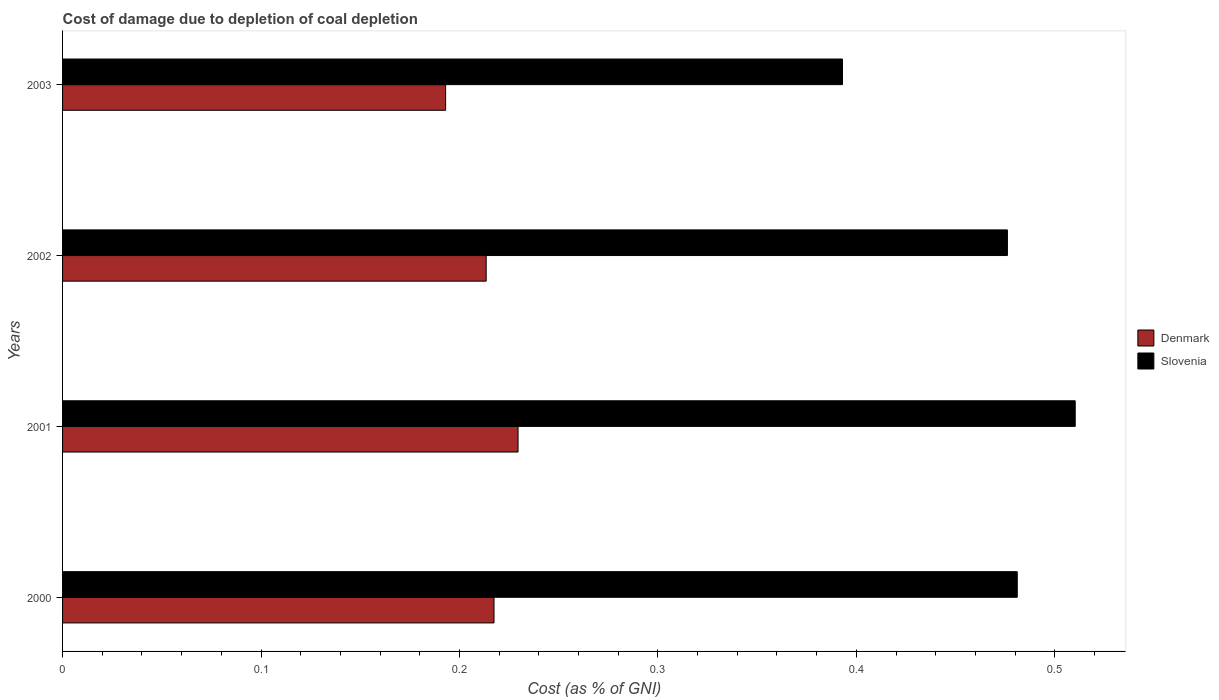Are the number of bars on each tick of the Y-axis equal?
Your answer should be compact. Yes. How many bars are there on the 4th tick from the top?
Your response must be concise. 2. How many bars are there on the 3rd tick from the bottom?
Offer a very short reply. 2. What is the label of the 1st group of bars from the top?
Provide a succinct answer. 2003. In how many cases, is the number of bars for a given year not equal to the number of legend labels?
Your response must be concise. 0. What is the cost of damage caused due to coal depletion in Slovenia in 2001?
Offer a terse response. 0.51. Across all years, what is the maximum cost of damage caused due to coal depletion in Slovenia?
Your answer should be compact. 0.51. Across all years, what is the minimum cost of damage caused due to coal depletion in Denmark?
Offer a terse response. 0.19. In which year was the cost of damage caused due to coal depletion in Slovenia maximum?
Give a very brief answer. 2001. What is the total cost of damage caused due to coal depletion in Slovenia in the graph?
Make the answer very short. 1.86. What is the difference between the cost of damage caused due to coal depletion in Denmark in 2002 and that in 2003?
Your answer should be compact. 0.02. What is the difference between the cost of damage caused due to coal depletion in Slovenia in 2003 and the cost of damage caused due to coal depletion in Denmark in 2002?
Make the answer very short. 0.18. What is the average cost of damage caused due to coal depletion in Slovenia per year?
Your answer should be very brief. 0.47. In the year 2000, what is the difference between the cost of damage caused due to coal depletion in Denmark and cost of damage caused due to coal depletion in Slovenia?
Your response must be concise. -0.26. What is the ratio of the cost of damage caused due to coal depletion in Slovenia in 2002 to that in 2003?
Offer a very short reply. 1.21. Is the cost of damage caused due to coal depletion in Denmark in 2001 less than that in 2003?
Provide a short and direct response. No. What is the difference between the highest and the second highest cost of damage caused due to coal depletion in Denmark?
Keep it short and to the point. 0.01. What is the difference between the highest and the lowest cost of damage caused due to coal depletion in Denmark?
Keep it short and to the point. 0.04. Are all the bars in the graph horizontal?
Make the answer very short. Yes. What is the difference between two consecutive major ticks on the X-axis?
Provide a short and direct response. 0.1. Does the graph contain grids?
Give a very brief answer. No. Where does the legend appear in the graph?
Offer a terse response. Center right. How many legend labels are there?
Ensure brevity in your answer.  2. What is the title of the graph?
Offer a terse response. Cost of damage due to depletion of coal depletion. What is the label or title of the X-axis?
Offer a very short reply. Cost (as % of GNI). What is the Cost (as % of GNI) in Denmark in 2000?
Your answer should be compact. 0.22. What is the Cost (as % of GNI) in Slovenia in 2000?
Offer a terse response. 0.48. What is the Cost (as % of GNI) in Denmark in 2001?
Provide a succinct answer. 0.23. What is the Cost (as % of GNI) in Slovenia in 2001?
Ensure brevity in your answer.  0.51. What is the Cost (as % of GNI) in Denmark in 2002?
Provide a succinct answer. 0.21. What is the Cost (as % of GNI) of Slovenia in 2002?
Offer a terse response. 0.48. What is the Cost (as % of GNI) in Denmark in 2003?
Ensure brevity in your answer.  0.19. What is the Cost (as % of GNI) of Slovenia in 2003?
Ensure brevity in your answer.  0.39. Across all years, what is the maximum Cost (as % of GNI) of Denmark?
Provide a succinct answer. 0.23. Across all years, what is the maximum Cost (as % of GNI) of Slovenia?
Make the answer very short. 0.51. Across all years, what is the minimum Cost (as % of GNI) of Denmark?
Offer a very short reply. 0.19. Across all years, what is the minimum Cost (as % of GNI) in Slovenia?
Offer a very short reply. 0.39. What is the total Cost (as % of GNI) of Denmark in the graph?
Your answer should be compact. 0.85. What is the total Cost (as % of GNI) in Slovenia in the graph?
Offer a very short reply. 1.86. What is the difference between the Cost (as % of GNI) of Denmark in 2000 and that in 2001?
Provide a short and direct response. -0.01. What is the difference between the Cost (as % of GNI) of Slovenia in 2000 and that in 2001?
Your answer should be compact. -0.03. What is the difference between the Cost (as % of GNI) of Denmark in 2000 and that in 2002?
Provide a succinct answer. 0. What is the difference between the Cost (as % of GNI) in Slovenia in 2000 and that in 2002?
Your answer should be compact. 0.01. What is the difference between the Cost (as % of GNI) in Denmark in 2000 and that in 2003?
Keep it short and to the point. 0.02. What is the difference between the Cost (as % of GNI) of Slovenia in 2000 and that in 2003?
Your answer should be compact. 0.09. What is the difference between the Cost (as % of GNI) of Denmark in 2001 and that in 2002?
Provide a succinct answer. 0.02. What is the difference between the Cost (as % of GNI) of Slovenia in 2001 and that in 2002?
Your answer should be compact. 0.03. What is the difference between the Cost (as % of GNI) of Denmark in 2001 and that in 2003?
Your response must be concise. 0.04. What is the difference between the Cost (as % of GNI) in Slovenia in 2001 and that in 2003?
Your response must be concise. 0.12. What is the difference between the Cost (as % of GNI) of Denmark in 2002 and that in 2003?
Keep it short and to the point. 0.02. What is the difference between the Cost (as % of GNI) of Slovenia in 2002 and that in 2003?
Ensure brevity in your answer.  0.08. What is the difference between the Cost (as % of GNI) in Denmark in 2000 and the Cost (as % of GNI) in Slovenia in 2001?
Provide a succinct answer. -0.29. What is the difference between the Cost (as % of GNI) of Denmark in 2000 and the Cost (as % of GNI) of Slovenia in 2002?
Your response must be concise. -0.26. What is the difference between the Cost (as % of GNI) in Denmark in 2000 and the Cost (as % of GNI) in Slovenia in 2003?
Your answer should be very brief. -0.18. What is the difference between the Cost (as % of GNI) in Denmark in 2001 and the Cost (as % of GNI) in Slovenia in 2002?
Make the answer very short. -0.25. What is the difference between the Cost (as % of GNI) in Denmark in 2001 and the Cost (as % of GNI) in Slovenia in 2003?
Keep it short and to the point. -0.16. What is the difference between the Cost (as % of GNI) in Denmark in 2002 and the Cost (as % of GNI) in Slovenia in 2003?
Offer a terse response. -0.18. What is the average Cost (as % of GNI) of Denmark per year?
Offer a very short reply. 0.21. What is the average Cost (as % of GNI) in Slovenia per year?
Give a very brief answer. 0.47. In the year 2000, what is the difference between the Cost (as % of GNI) of Denmark and Cost (as % of GNI) of Slovenia?
Your response must be concise. -0.26. In the year 2001, what is the difference between the Cost (as % of GNI) of Denmark and Cost (as % of GNI) of Slovenia?
Ensure brevity in your answer.  -0.28. In the year 2002, what is the difference between the Cost (as % of GNI) of Denmark and Cost (as % of GNI) of Slovenia?
Your answer should be compact. -0.26. In the year 2003, what is the difference between the Cost (as % of GNI) of Denmark and Cost (as % of GNI) of Slovenia?
Your response must be concise. -0.2. What is the ratio of the Cost (as % of GNI) of Denmark in 2000 to that in 2001?
Keep it short and to the point. 0.95. What is the ratio of the Cost (as % of GNI) of Slovenia in 2000 to that in 2001?
Ensure brevity in your answer.  0.94. What is the ratio of the Cost (as % of GNI) in Denmark in 2000 to that in 2002?
Your response must be concise. 1.02. What is the ratio of the Cost (as % of GNI) in Slovenia in 2000 to that in 2002?
Offer a terse response. 1.01. What is the ratio of the Cost (as % of GNI) of Denmark in 2000 to that in 2003?
Offer a very short reply. 1.13. What is the ratio of the Cost (as % of GNI) in Slovenia in 2000 to that in 2003?
Keep it short and to the point. 1.22. What is the ratio of the Cost (as % of GNI) of Denmark in 2001 to that in 2002?
Offer a terse response. 1.08. What is the ratio of the Cost (as % of GNI) of Slovenia in 2001 to that in 2002?
Provide a short and direct response. 1.07. What is the ratio of the Cost (as % of GNI) in Denmark in 2001 to that in 2003?
Make the answer very short. 1.19. What is the ratio of the Cost (as % of GNI) in Slovenia in 2001 to that in 2003?
Ensure brevity in your answer.  1.3. What is the ratio of the Cost (as % of GNI) of Denmark in 2002 to that in 2003?
Offer a very short reply. 1.11. What is the ratio of the Cost (as % of GNI) in Slovenia in 2002 to that in 2003?
Give a very brief answer. 1.21. What is the difference between the highest and the second highest Cost (as % of GNI) in Denmark?
Keep it short and to the point. 0.01. What is the difference between the highest and the second highest Cost (as % of GNI) in Slovenia?
Offer a very short reply. 0.03. What is the difference between the highest and the lowest Cost (as % of GNI) of Denmark?
Ensure brevity in your answer.  0.04. What is the difference between the highest and the lowest Cost (as % of GNI) in Slovenia?
Keep it short and to the point. 0.12. 